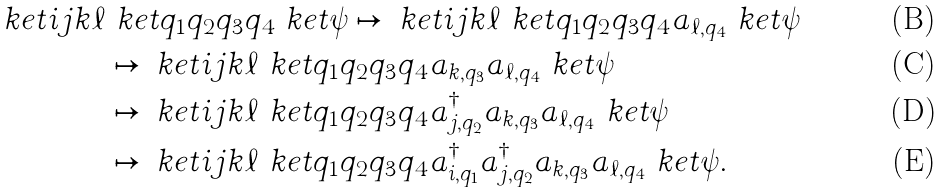Convert formula to latex. <formula><loc_0><loc_0><loc_500><loc_500>\ k e t { i j k \ell } & \ k e t { q _ { 1 } q _ { 2 } q _ { 3 } q _ { 4 } } \ k e t { \psi } \mapsto \ k e t { i j k \ell } \ k e t { q _ { 1 } q _ { 2 } q _ { 3 } q _ { 4 } } a _ { \ell , q _ { 4 } } \ k e t { \psi } \\ & \mapsto \ k e t { i j k \ell } \ k e t { q _ { 1 } q _ { 2 } q _ { 3 } q _ { 4 } } a _ { k , q _ { 3 } } a _ { \ell , q _ { 4 } } \ k e t { \psi } \\ & \mapsto \ k e t { i j k \ell } \ k e t { q _ { 1 } q _ { 2 } q _ { 3 } q _ { 4 } } a ^ { \dagger } _ { j , q _ { 2 } } a _ { k , q _ { 3 } } a _ { \ell , q _ { 4 } } \ k e t { \psi } \\ & \mapsto \ k e t { i j k \ell } \ k e t { q _ { 1 } q _ { 2 } q _ { 3 } q _ { 4 } } a ^ { \dagger } _ { i , q _ { 1 } } a ^ { \dagger } _ { j , q _ { 2 } } a _ { k , q _ { 3 } } a _ { \ell , q _ { 4 } } \ k e t { \psi } .</formula> 